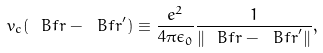<formula> <loc_0><loc_0><loc_500><loc_500>v _ { c } ( { \ B f r } - { \ B f r } ^ { \prime } ) \equiv \frac { e ^ { 2 } } { 4 \pi \epsilon _ { 0 } } \frac { 1 } { \| { \ B f r } - { \ B f r } ^ { \prime } \| } ,</formula> 